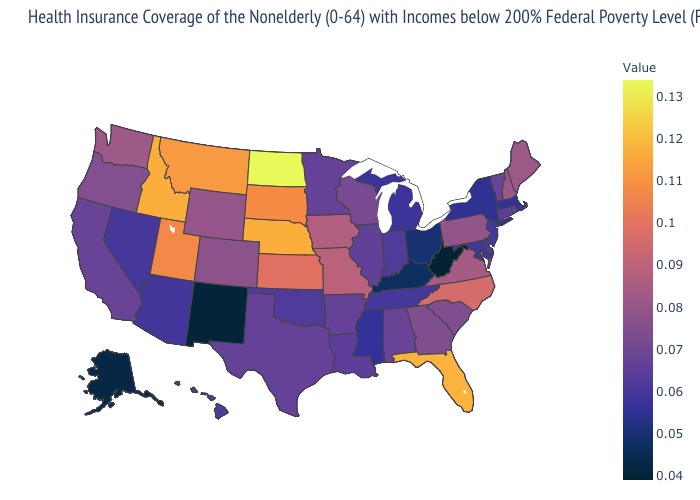Which states have the lowest value in the USA?
Concise answer only. West Virginia. Does West Virginia have the lowest value in the USA?
Keep it brief. Yes. Is the legend a continuous bar?
Write a very short answer. Yes. Which states have the highest value in the USA?
Quick response, please. North Dakota. Is the legend a continuous bar?
Short answer required. Yes. Does Hawaii have a lower value than West Virginia?
Write a very short answer. No. 